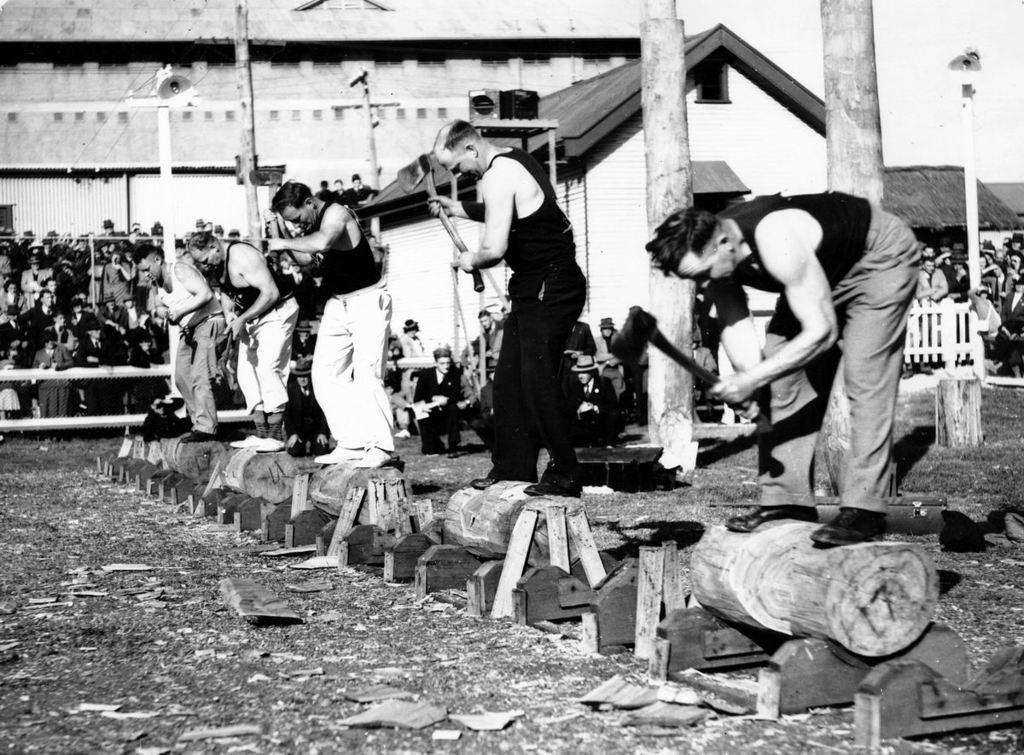Could you give a brief overview of what you see in this image? In this image we can see five men standing on the small wooden log and they are holding the axes in their hands. Here we can see the broken wooden pieces on the ground. Here we can see the trunk of trees on the right side. In the background, we can see the spectators and houses. 